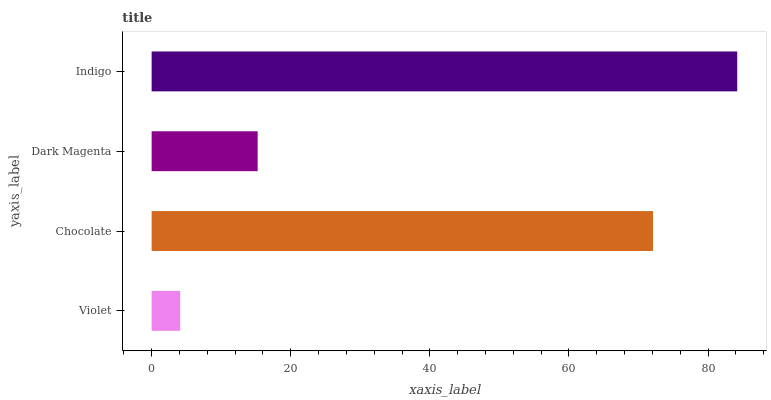Is Violet the minimum?
Answer yes or no. Yes. Is Indigo the maximum?
Answer yes or no. Yes. Is Chocolate the minimum?
Answer yes or no. No. Is Chocolate the maximum?
Answer yes or no. No. Is Chocolate greater than Violet?
Answer yes or no. Yes. Is Violet less than Chocolate?
Answer yes or no. Yes. Is Violet greater than Chocolate?
Answer yes or no. No. Is Chocolate less than Violet?
Answer yes or no. No. Is Chocolate the high median?
Answer yes or no. Yes. Is Dark Magenta the low median?
Answer yes or no. Yes. Is Dark Magenta the high median?
Answer yes or no. No. Is Indigo the low median?
Answer yes or no. No. 